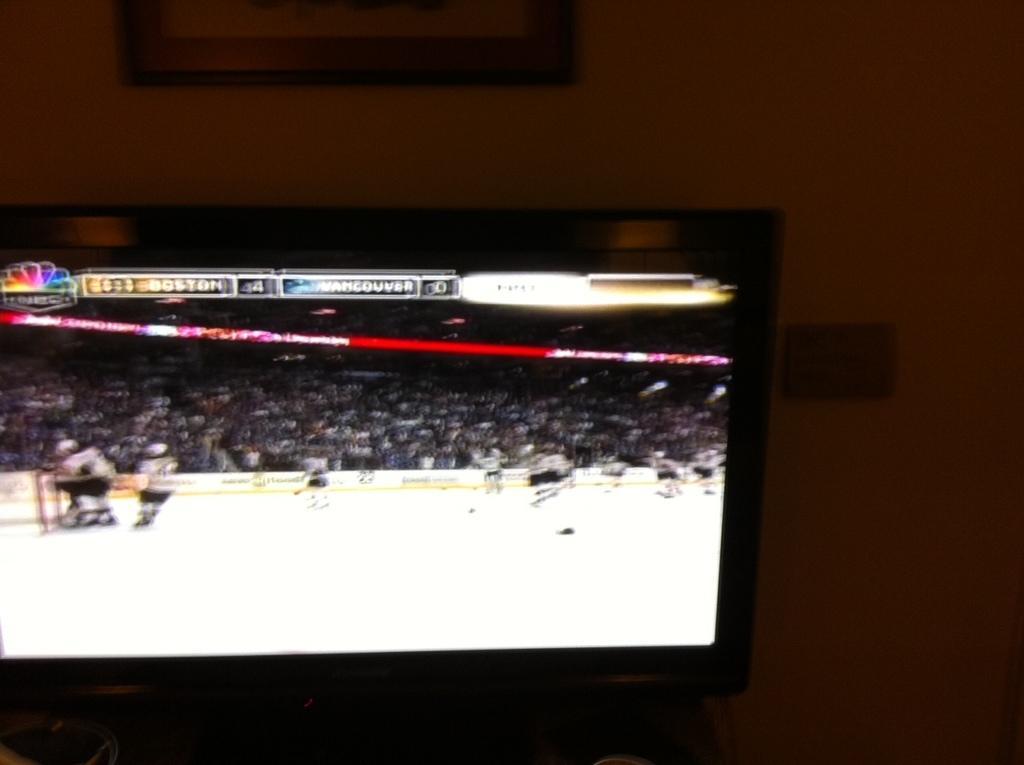Can you describe this image briefly? In this picture we can see a screen and on this screen we can see a group of people, some people on the ground, some text and in the background we can see a frame on the wall. 